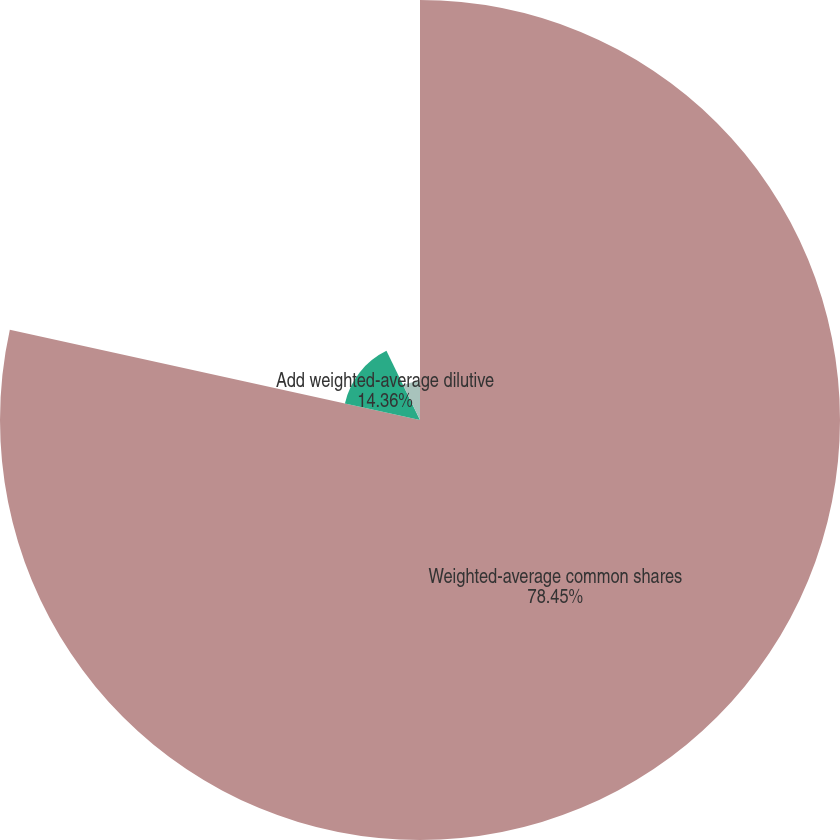Convert chart. <chart><loc_0><loc_0><loc_500><loc_500><pie_chart><fcel>Weighted-average common shares<fcel>Add weighted-average dilutive<fcel>Basic<fcel>Diluted<nl><fcel>78.45%<fcel>14.36%<fcel>7.18%<fcel>0.01%<nl></chart> 